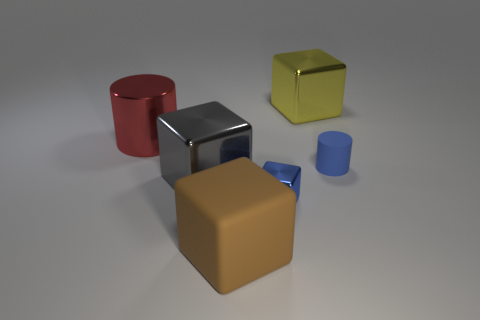What number of tiny blue objects are there?
Provide a succinct answer. 2. Does the cylinder to the left of the blue matte object have the same material as the brown cube?
Your response must be concise. No. What is the material of the object that is both on the left side of the tiny blue cube and in front of the gray object?
Your response must be concise. Rubber. What material is the cylinder that is to the right of the large block behind the big metal cylinder?
Offer a terse response. Rubber. There is a rubber thing that is on the left side of the matte thing behind the block that is in front of the small cube; what size is it?
Offer a terse response. Large. What number of large yellow objects are the same material as the tiny cylinder?
Give a very brief answer. 0. There is a cylinder to the left of the matte thing that is on the right side of the large yellow block; what is its color?
Your answer should be compact. Red. What number of objects are either large brown metallic cylinders or objects in front of the large metallic cylinder?
Keep it short and to the point. 4. Are there any objects that have the same color as the tiny matte cylinder?
Make the answer very short. Yes. What number of purple objects are either large spheres or small blocks?
Give a very brief answer. 0. 